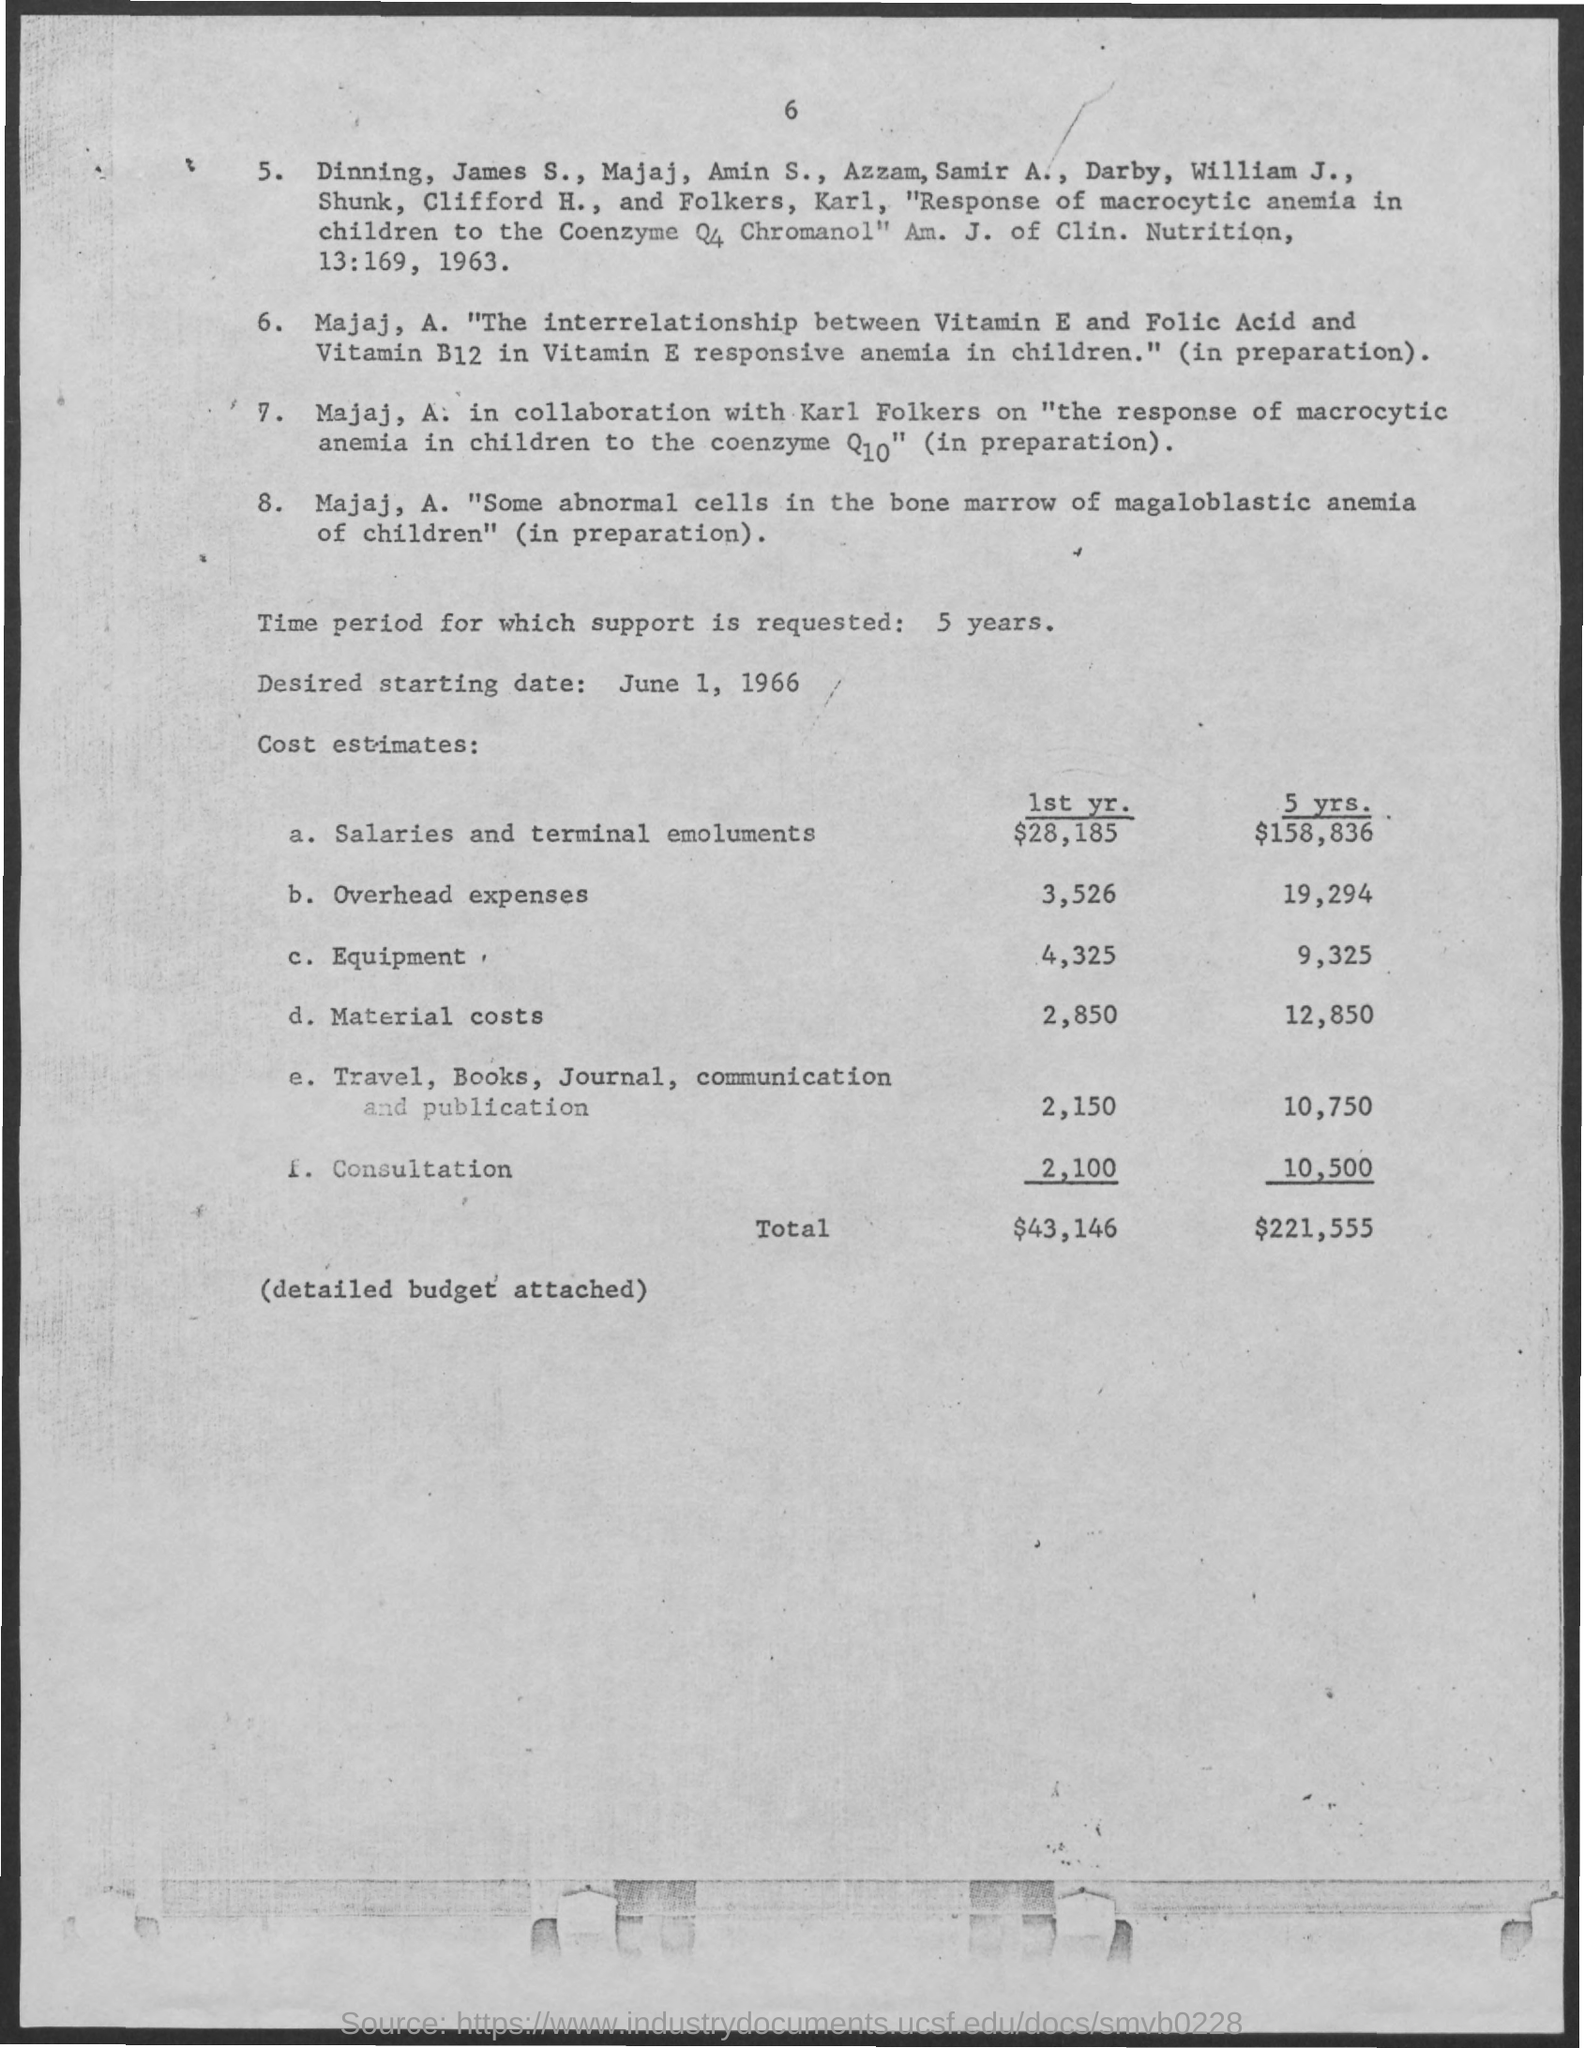Give some essential details in this illustration. Support is requested for a time period of five years. The cost estimate for overhead expenses over the next five years is approximately 19,294. The estimated cost for equipment over a five-year period is 9,325. The cost estimate for material costs for the next five years is 12,850. We have estimated the cost of equipment for the first year to be approximately $4,325. 